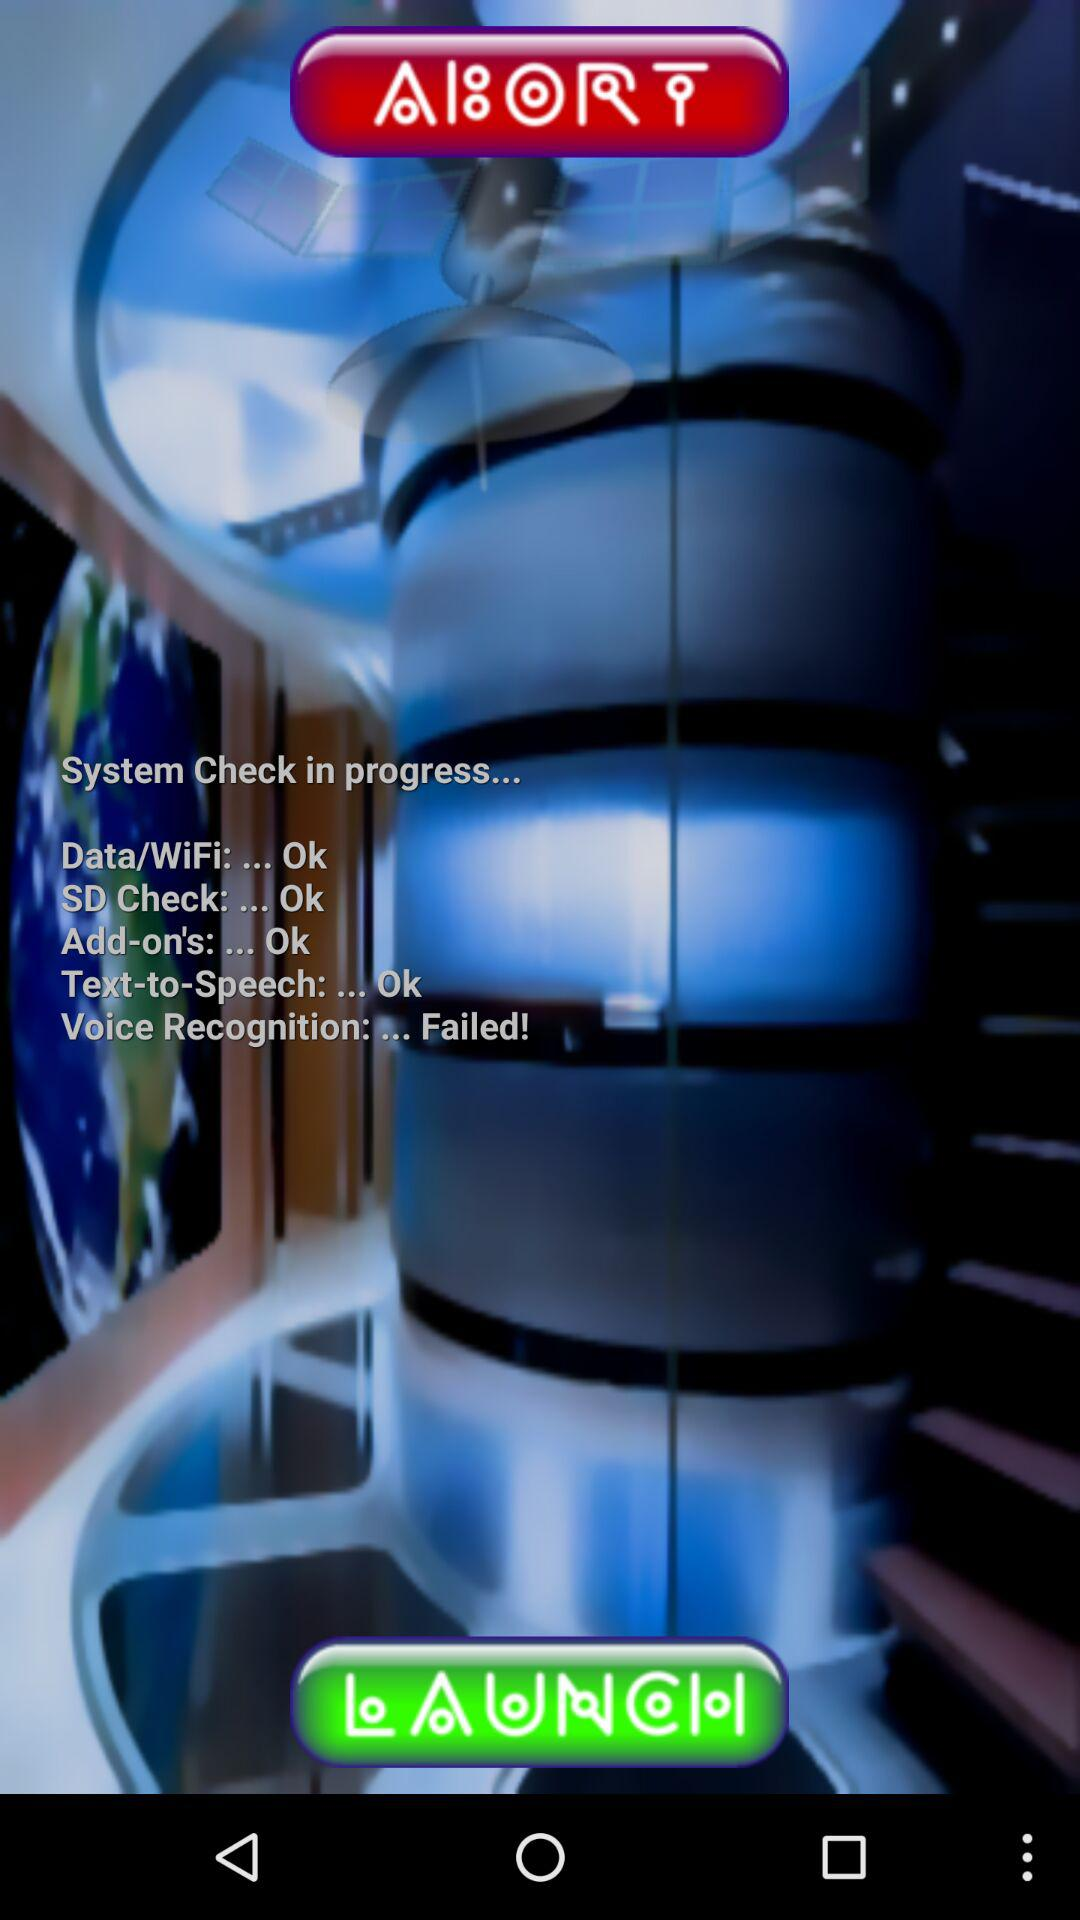How many tests are successful?
Answer the question using a single word or phrase. 4 